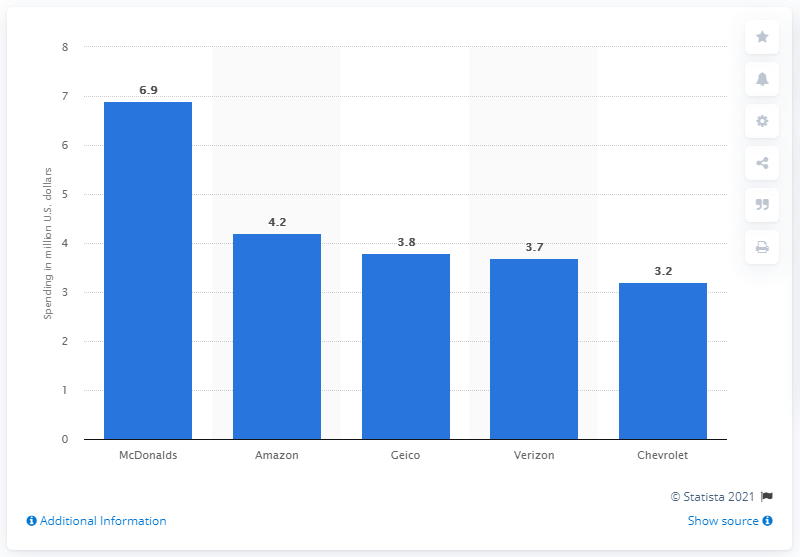Specify some key components in this picture. During the presented week, McDonald's invested 6.9 million dollars on new creatives for their advertisements that aired on U.S. national television. 